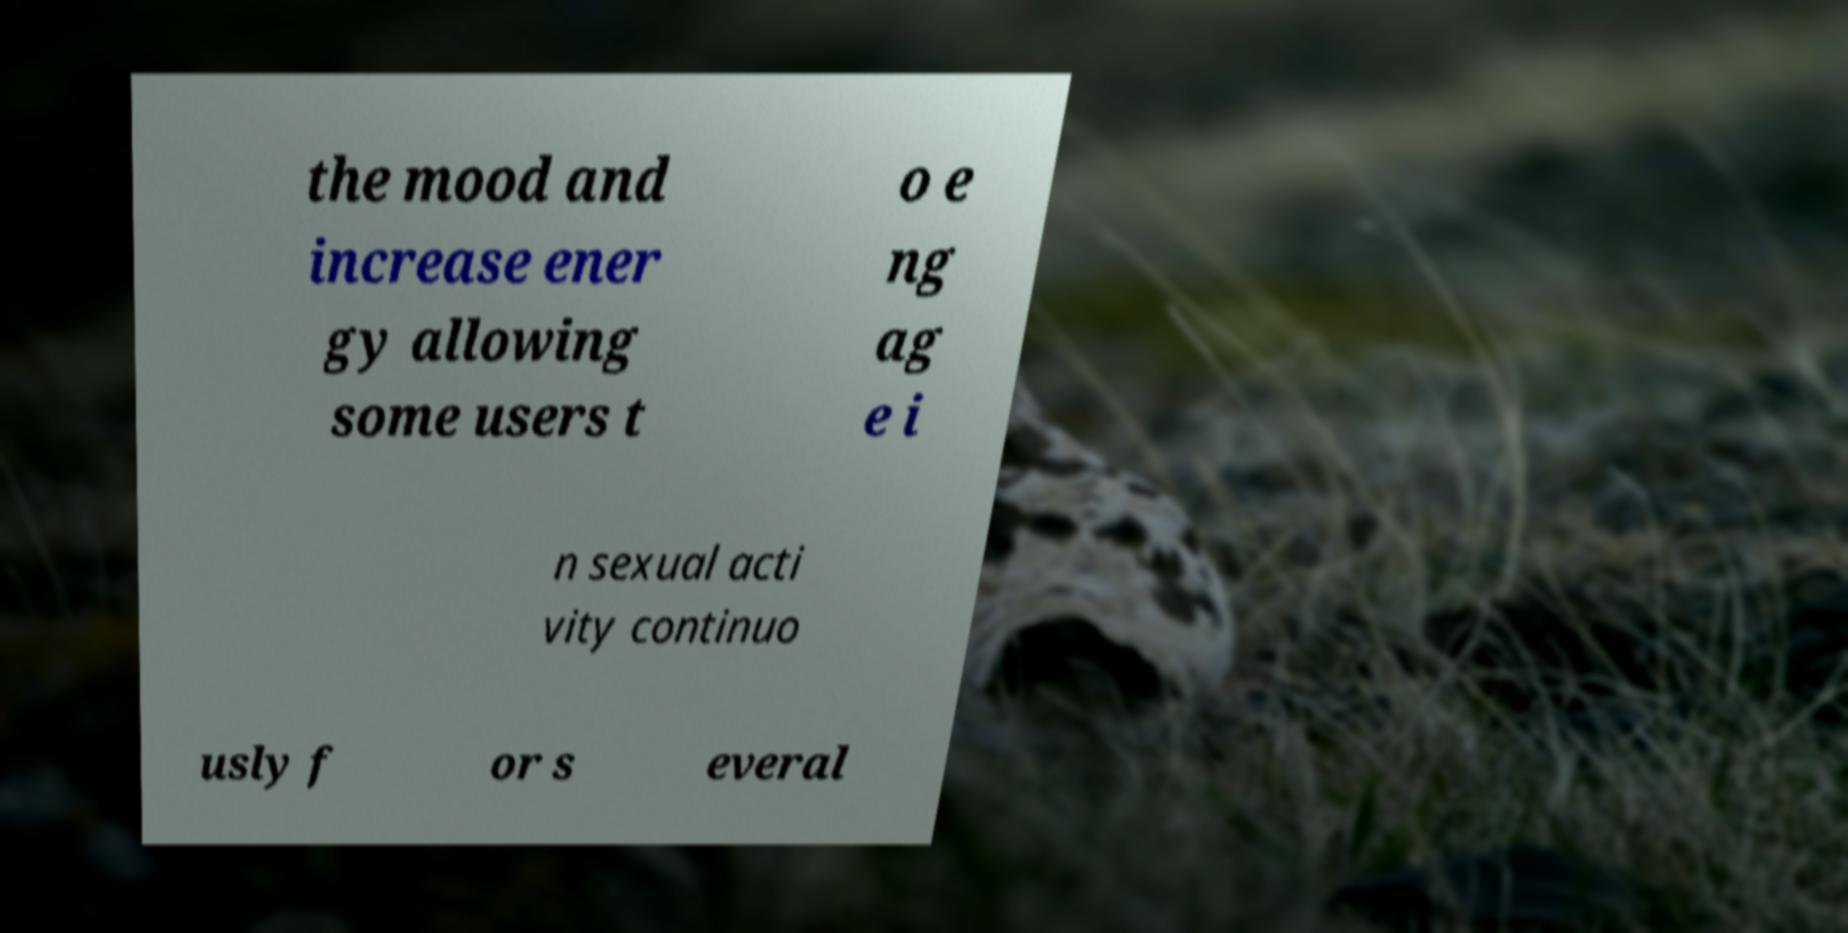I need the written content from this picture converted into text. Can you do that? the mood and increase ener gy allowing some users t o e ng ag e i n sexual acti vity continuo usly f or s everal 